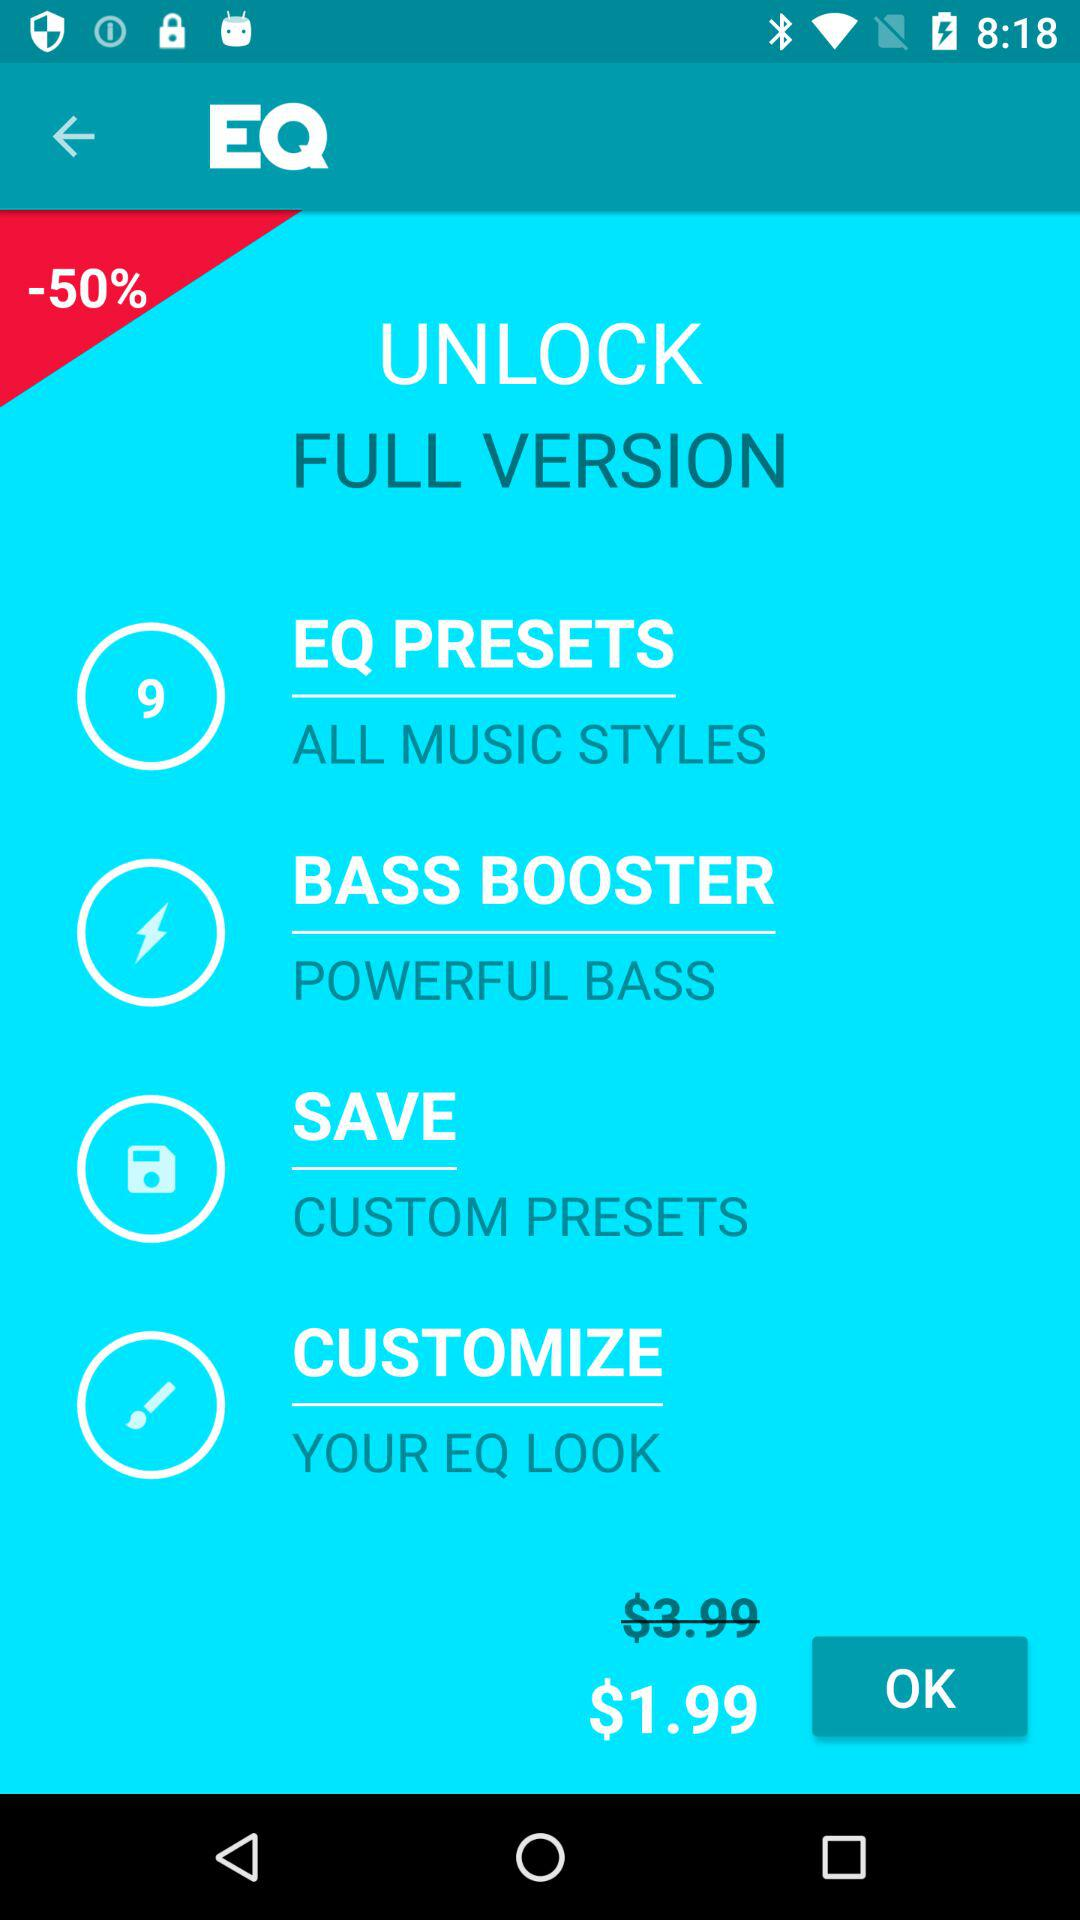What is the price of the full version? The price of the full version is $1.99. 